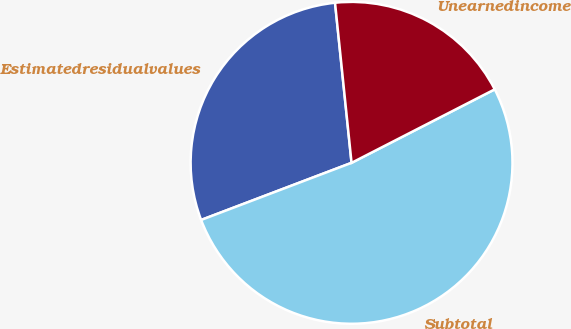Convert chart. <chart><loc_0><loc_0><loc_500><loc_500><pie_chart><fcel>Estimatedresidualvalues<fcel>Subtotal<fcel>Unearnedincome<nl><fcel>29.14%<fcel>51.77%<fcel>19.09%<nl></chart> 